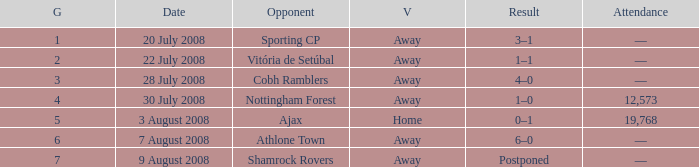What is the total game number with athlone town as the opponent? 1.0. 